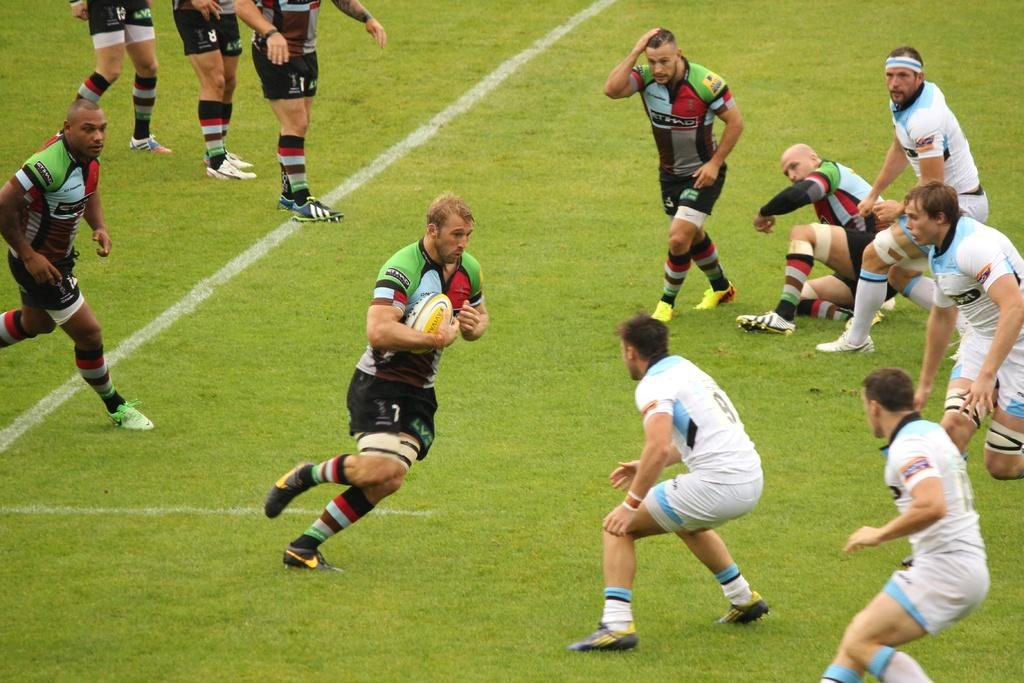<image>
Create a compact narrative representing the image presented. a player in a rugby match that is running by number 9 